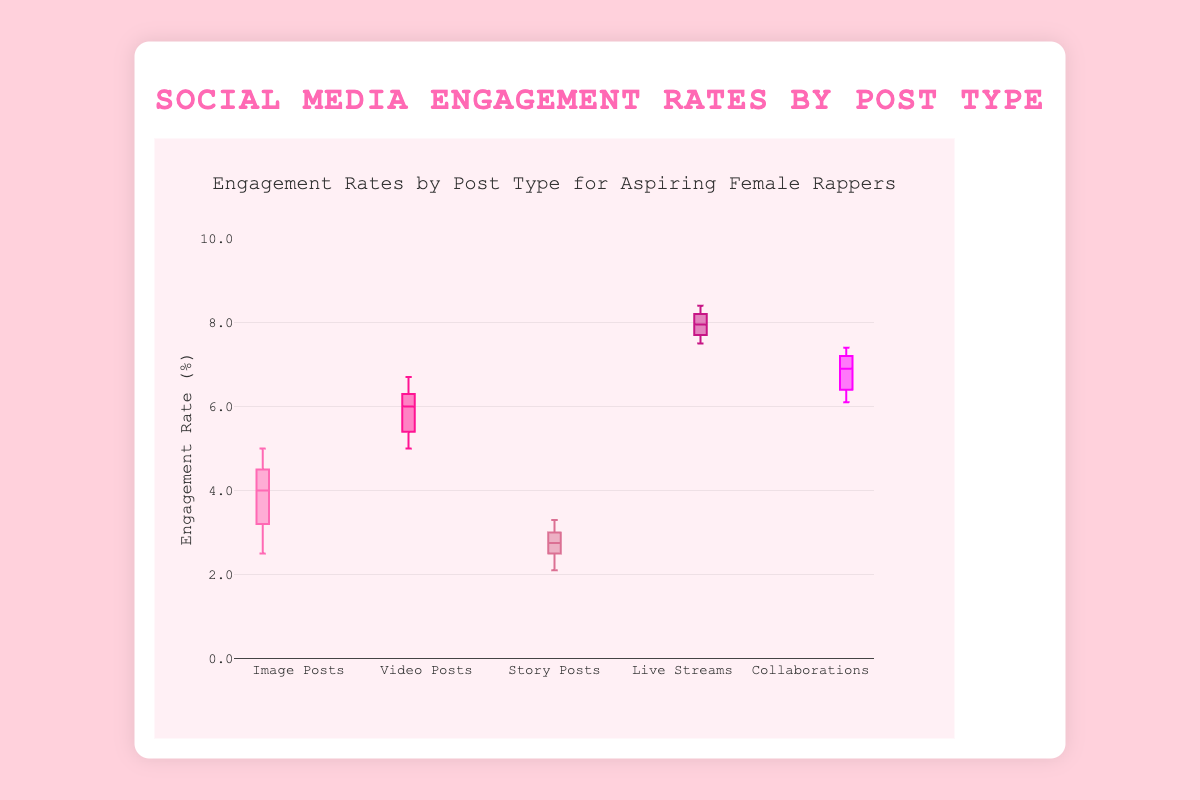What's the title of the figure? The title of the figure is displayed at the top in larger text, it is "Social Media Engagement Rates by Post Type".
Answer: Social Media Engagement Rates by Post Type Which post type has the highest median engagement rate? The median value of each boxplot is indicated by the line inside the box. The post type with the highest median line is "Live Streams".
Answer: Live Streams What is the range of engagement rates for Image Posts? The range is given by the distance between the minimum and maximum values of the boxplot for Image Posts. It extends from 2.5% to 5.0%.
Answer: 2.5% to 5.0% Which post type has the lowest engagement rate overall? The lowest engagement rate refers to the smallest value among all the boxplots, which appears in the Story Posts with an engagement rate of 2.1%.
Answer: Story Posts Compare the interquartile ranges (IQRs) of Video Posts and Collaborations. Which one is higher? The interquartile range (IQR) is the difference between the upper quartile (top of the box) and the lower quartile (bottom of the box). For Video Posts, it's from about 5.8% to 6.4%. For Collaborations, it's from about 6.4% to 7.2%. The IQR for Collaborations is higher.
Answer: Collaborations What is the median engagement rate for Story Posts? The median is the line inside the box of the boxplot for Story Posts, which is at 2.75%.
Answer: 2.75% Are there any post types where the engagement rates exceed 8%? If yes, which ones? The only boxplot that goes beyond 8% is for Live Streams. The maximum value for Live Streams exceeds 8.4%.
Answer: Live Streams How much higher is the median engagement rate of Live Streams compared to Story Posts? The median engagement rate for Live Streams is approximately 8.0% and for Story Posts is 2.75%. The difference is 8.0% - 2.75% = 5.25%.
Answer: 5.25% Which post type shows more variability in engagement rates, Image Posts or Story Posts? Variability can be assessed by looking at the spread of the boxplots. The spread (range) of the boxplot for Image Posts is larger (2.5% to 5.0%) compared to Story Posts (2.1% to 3.3%), indicating more variability in engagement rates for Image Posts.
Answer: Image Posts 